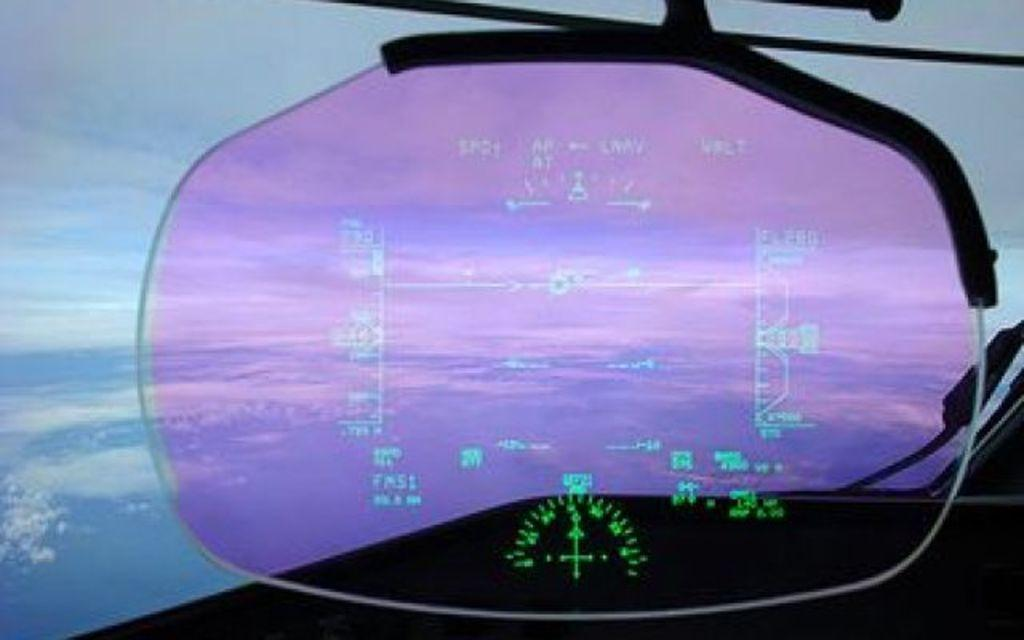What object is located in the front of the image? There is a glass in the front of the image. What can be seen in the background of the image? The sky is visible in the background of the image. How would you describe the sky in the image? The sky is cloudy in the image. What grade does the clover receive in the image? There is no clover present in the image, so it cannot receive a grade. 